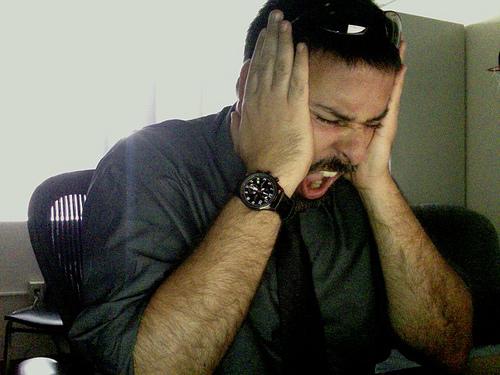Can you see any teeth?
Be succinct. Yes. Is this person mad?
Answer briefly. Yes. What is on the man's right wrist?
Give a very brief answer. Watch. 